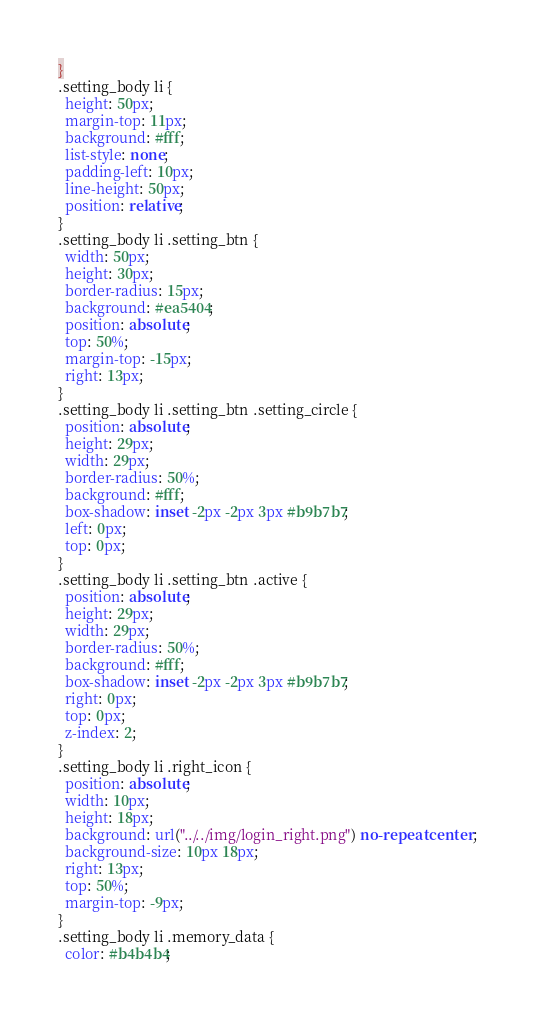Convert code to text. <code><loc_0><loc_0><loc_500><loc_500><_CSS_>}
.setting_body li {
  height: 50px;
  margin-top: 11px;
  background: #fff;
  list-style: none;
  padding-left: 10px;
  line-height: 50px;
  position: relative;
}
.setting_body li .setting_btn {
  width: 50px;
  height: 30px;
  border-radius: 15px;
  background: #ea5404;
  position: absolute;
  top: 50%;
  margin-top: -15px;
  right: 13px;
}
.setting_body li .setting_btn .setting_circle {
  position: absolute;
  height: 29px;
  width: 29px;
  border-radius: 50%;
  background: #fff;
  box-shadow: inset -2px -2px 3px #b9b7b7;
  left: 0px;
  top: 0px;
}
.setting_body li .setting_btn .active {
  position: absolute;
  height: 29px;
  width: 29px;
  border-radius: 50%;
  background: #fff;
  box-shadow: inset -2px -2px 3px #b9b7b7;
  right: 0px;
  top: 0px;
  z-index: 2;
}
.setting_body li .right_icon {
  position: absolute;
  width: 10px;
  height: 18px;
  background: url("../../img/login_right.png") no-repeat center;
  background-size: 10px 18px;
  right: 13px;
  top: 50%;
  margin-top: -9px;
}
.setting_body li .memory_data {
  color: #b4b4b4;</code> 